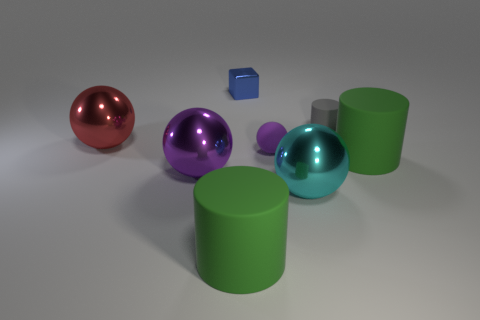Subtract 1 balls. How many balls are left? 3 Add 1 tiny purple rubber spheres. How many objects exist? 9 Subtract all cylinders. How many objects are left? 5 Add 5 small purple matte balls. How many small purple matte balls are left? 6 Add 7 large spheres. How many large spheres exist? 10 Subtract 0 brown blocks. How many objects are left? 8 Subtract all small blue metallic cubes. Subtract all tiny blue things. How many objects are left? 6 